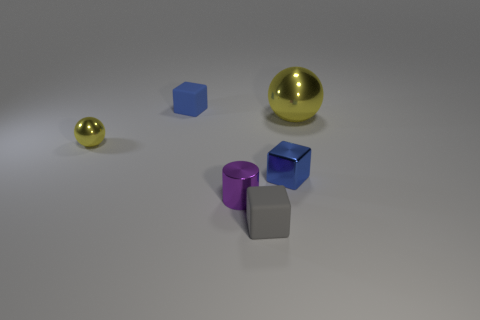Add 3 small blue objects. How many objects exist? 9 Subtract all balls. How many objects are left? 4 Subtract 0 purple balls. How many objects are left? 6 Subtract all small cyan shiny blocks. Subtract all tiny gray rubber things. How many objects are left? 5 Add 2 rubber objects. How many rubber objects are left? 4 Add 2 small yellow rubber cylinders. How many small yellow rubber cylinders exist? 2 